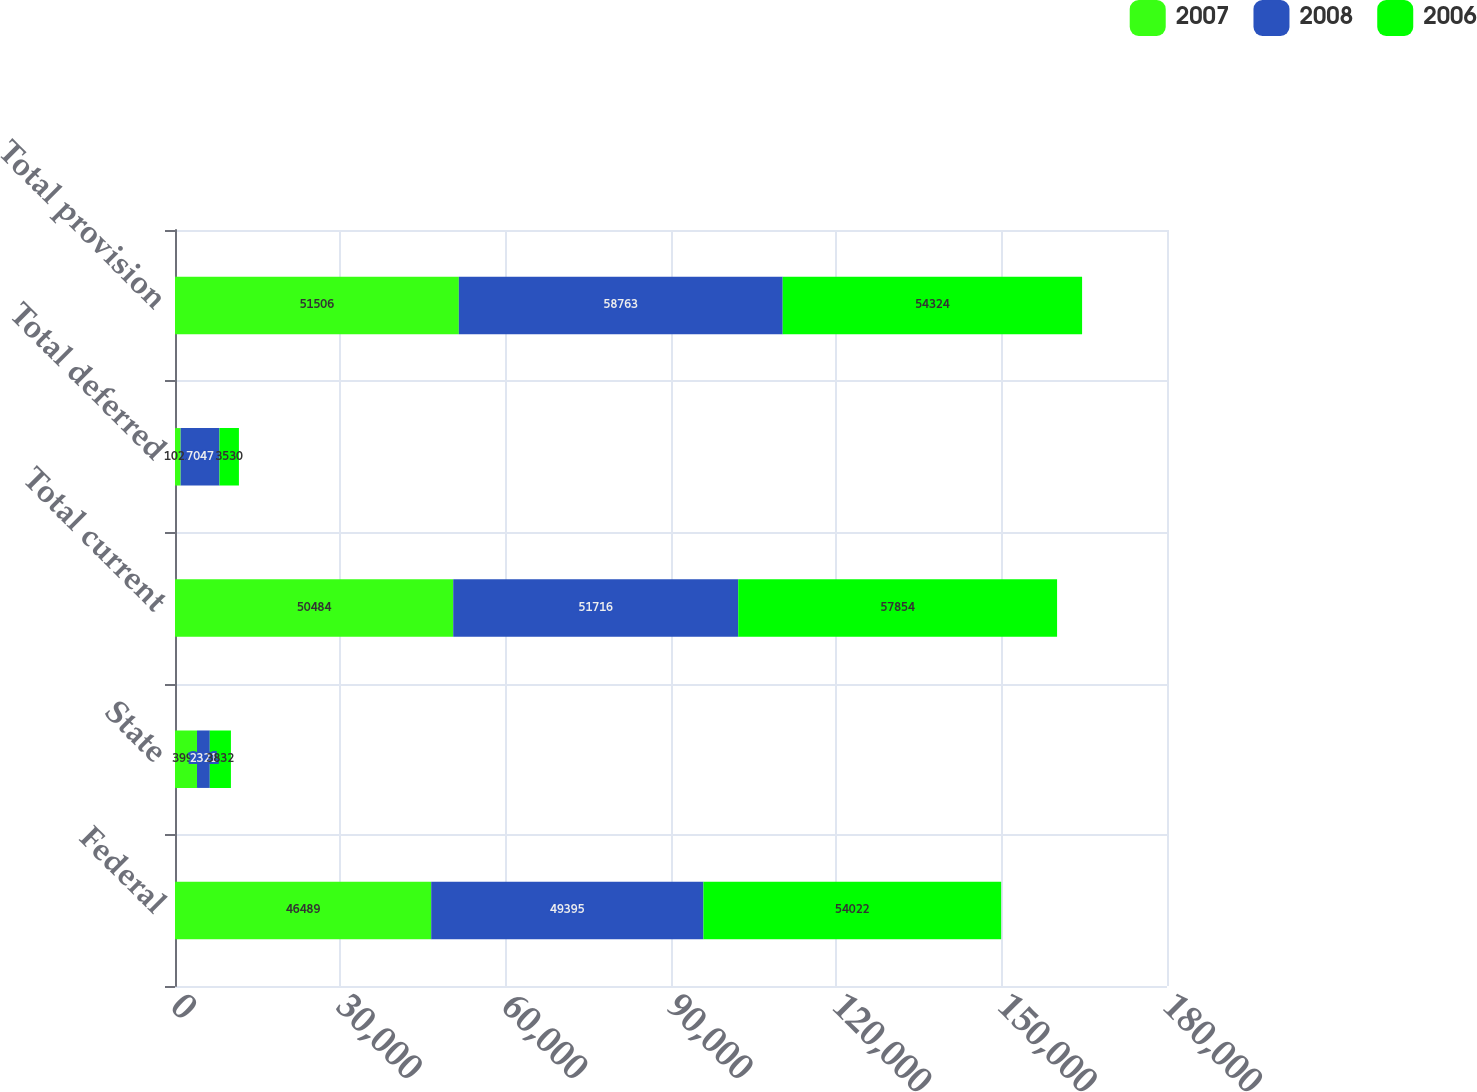Convert chart to OTSL. <chart><loc_0><loc_0><loc_500><loc_500><stacked_bar_chart><ecel><fcel>Federal<fcel>State<fcel>Total current<fcel>Total deferred<fcel>Total provision<nl><fcel>2007<fcel>46489<fcel>3995<fcel>50484<fcel>1022<fcel>51506<nl><fcel>2008<fcel>49395<fcel>2321<fcel>51716<fcel>7047<fcel>58763<nl><fcel>2006<fcel>54022<fcel>3832<fcel>57854<fcel>3530<fcel>54324<nl></chart> 